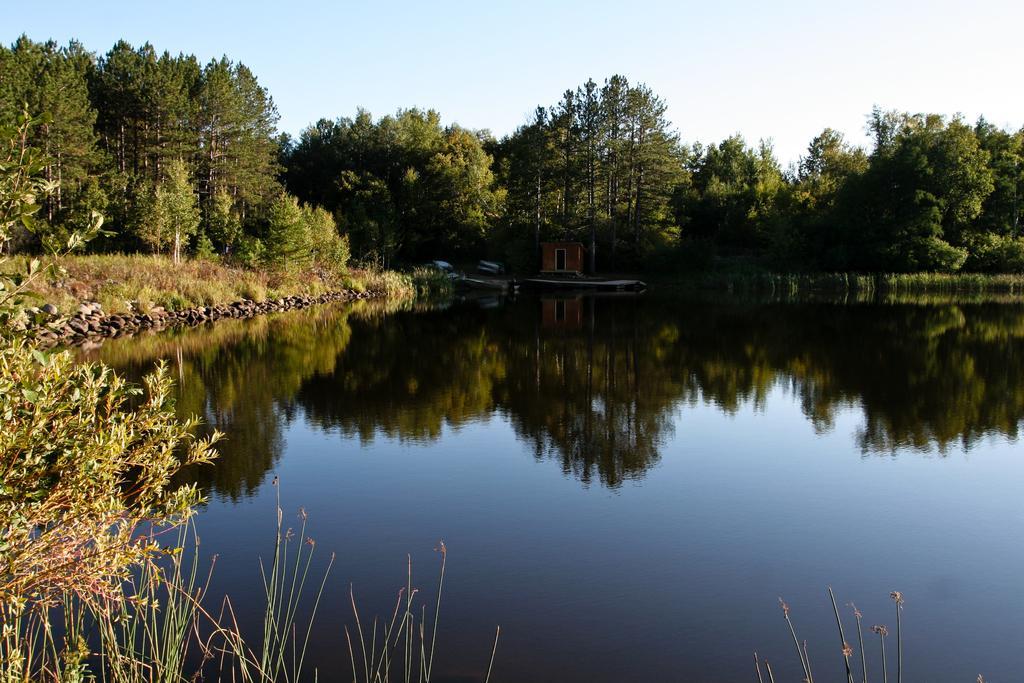Can you describe this image briefly? There is water. On the left side there are stones, plants and trees. In the back there is a small building and trees. In the background there is sky. 